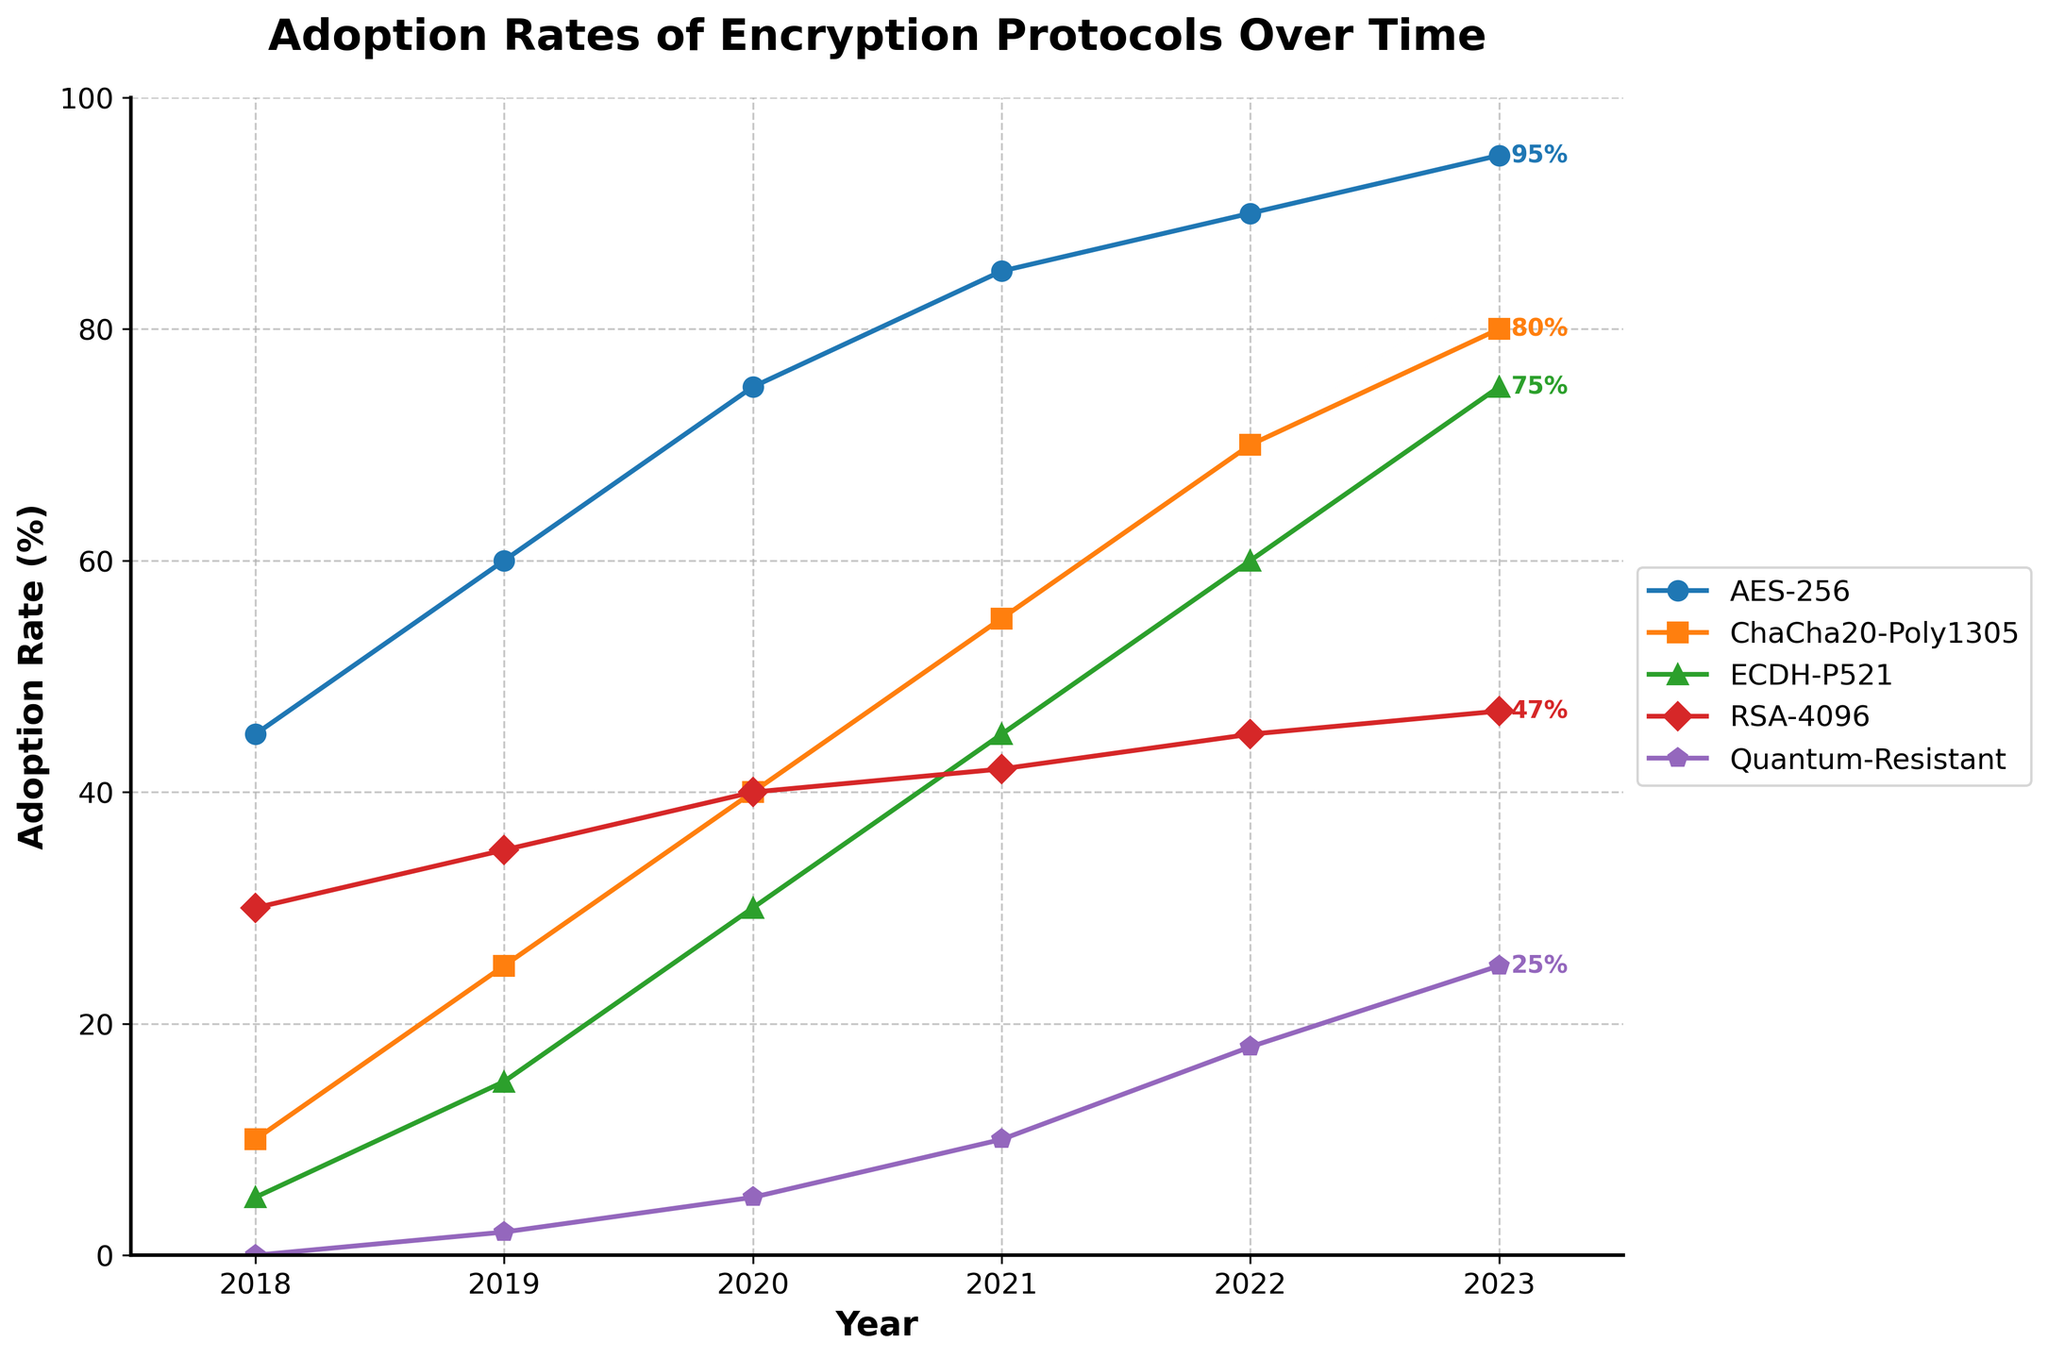Which encryption protocol saw the greatest increase in adoption from 2018 to 2023? Look at the adoption rates of each protocol in 2018 and 2023. Calculate the difference for each and compare them. AES-256 increased from 45% to 95% (50%), ChaCha20-Poly1305 from 10% to 80% (70%), ECDH-P521 from 5% to 75% (70%), RSA-4096 from 30% to 47% (17%), and Quantum-Resistant from 0% to 25% (25%).
Answer: ChaCha20-Poly1305 and ECDH-P521 Which protocol had the least adoption rate in 2020? Refer to the adoption rates in 2020 for all protocols. Compare them to identify the smallest value. AES-256 is 75%, ChaCha20-Poly1305 is 40%, ECDH-P521 is 30%, RSA-4096 is 40%, and Quantum-Resistant is 5%. The lowest value is 5%.
Answer: Quantum-Resistant What was the adoption rate of RSA-4096 in 2021? Look at the value of RSA-4096 in the year 2021 on the chart. The adoption rate is shown to be 42%.
Answer: 42% Compare the adoption rates of ECDH-P521 and AES-256 in 2023. Check the adoption rates for both protocols in 2023 on the chart. AES-256 has an adoption rate of 95%, and ECDH-P521 has 75%. AES-256 has a higher adoption rate by 20%.
Answer: AES-256 is 20% higher Which protocol's adoption rates grew more rapidly between 2018 to 2023, ECDH-P521 or Quantum-Resistant? Calculate the growth rates by taking the difference between the adoption rates in 2023 and 2018 for both protocols. ECDH-P521 grew by 70% (75% - 5%), while Quantum-Resistant grew by 25% (25% - 0%).
Answer: ECDH-P521 What is the sum of the adoption rates of all protocols in 2022? Check the adoption rates of the protocols in 2022: AES-256 (90%), ChaCha20-Poly1305 (70%), ECDH-P521 (60%), RSA-4096 (45%), and Quantum-Resistant (18%). Sum these values: 90 + 70 + 60 + 45 + 18 = 283.
Answer: 283% Which protocol saw a consistent year-over-year increase in adoption rates? Analyze the trend for each protocol to see if the adoption rate increases each year. AES-256 shows a consistent increase: 45%, 60%, 75%, 85%, 90%, 95%.
Answer: AES-256 What is the difference in the adoption rates of ChaCha20-Poly1305 and RSA-4096 in 2020? Look at the adoption rates in 2020 for both protocols: ChaCha20-Poly1305 (40%) and RSA-4096 (40%). Calculate the difference: 40% - 40% = 0%.
Answer: 0% What was the average adoption rate of AES-256 from 2018 to 2023? Sum the adoption rates of AES-256 from 2018 to 2023: 45 + 60 + 75 + 85 + 90 + 95 = 450. There are 6 data points from 2018 to 2023, so the average is 450 / 6 = 75.
Answer: 75% How many protocols had adoption rates above 50% in 2021? Look at the adoption rates in 2021: AES-256 (85%), ChaCha20-Poly1305 (55%), ECDH-P521 (45%), RSA-4096 (42%), and Quantum-Resistant (10%). Count the protocols above 50%: AES-256, ChaCha20-Poly1305.
Answer: 2 